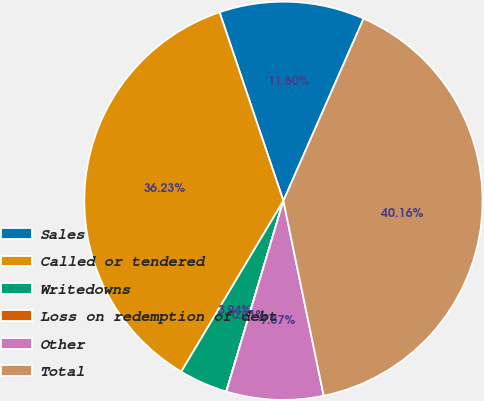Convert chart. <chart><loc_0><loc_0><loc_500><loc_500><pie_chart><fcel>Sales<fcel>Called or tendered<fcel>Writedowns<fcel>Loss on redemption of debt<fcel>Other<fcel>Total<nl><fcel>11.8%<fcel>36.23%<fcel>3.94%<fcel>0.01%<fcel>7.87%<fcel>40.16%<nl></chart> 